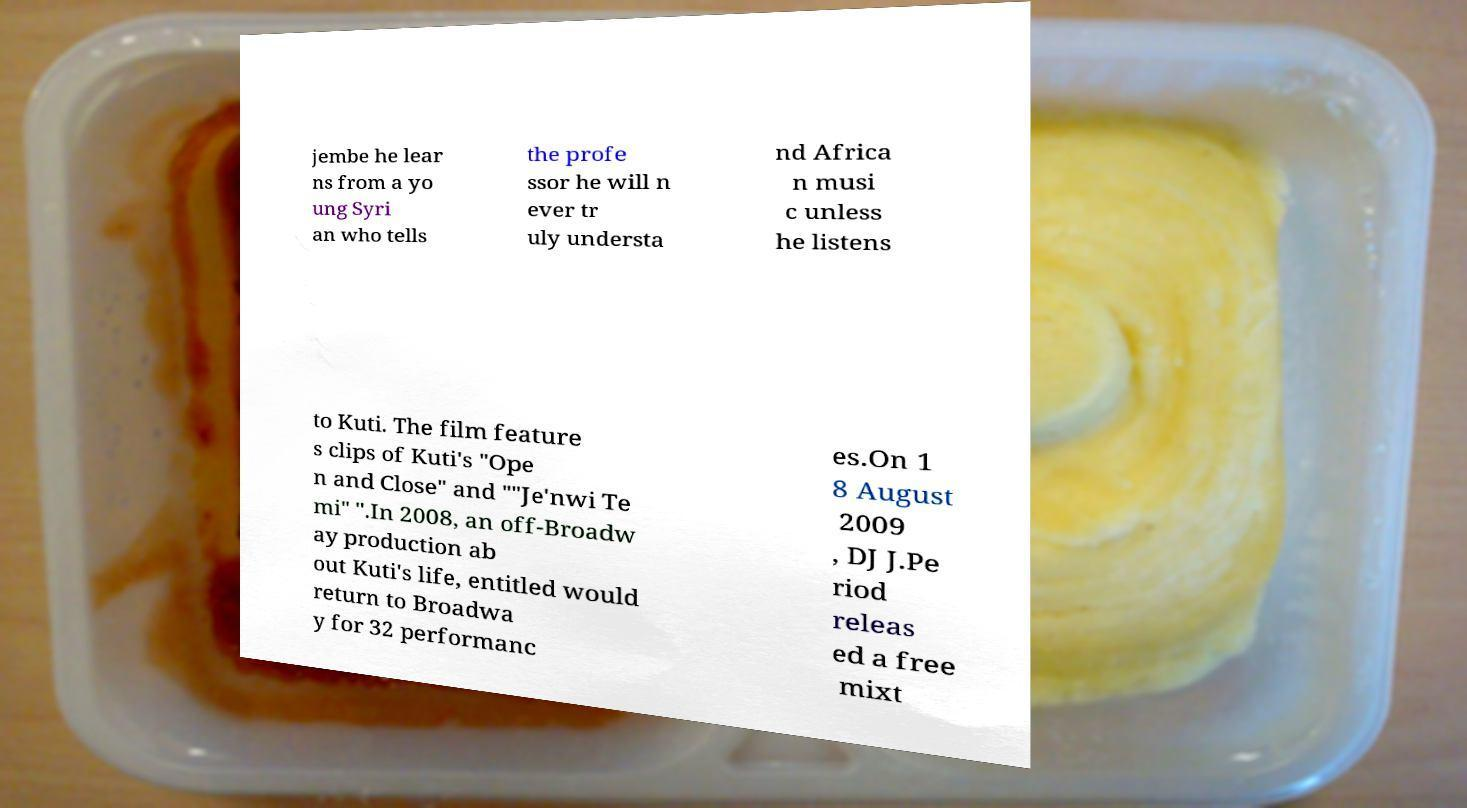Please identify and transcribe the text found in this image. jembe he lear ns from a yo ung Syri an who tells the profe ssor he will n ever tr uly understa nd Africa n musi c unless he listens to Kuti. The film feature s clips of Kuti's "Ope n and Close" and ""Je'nwi Te mi" ".In 2008, an off-Broadw ay production ab out Kuti's life, entitled would return to Broadwa y for 32 performanc es.On 1 8 August 2009 , DJ J.Pe riod releas ed a free mixt 